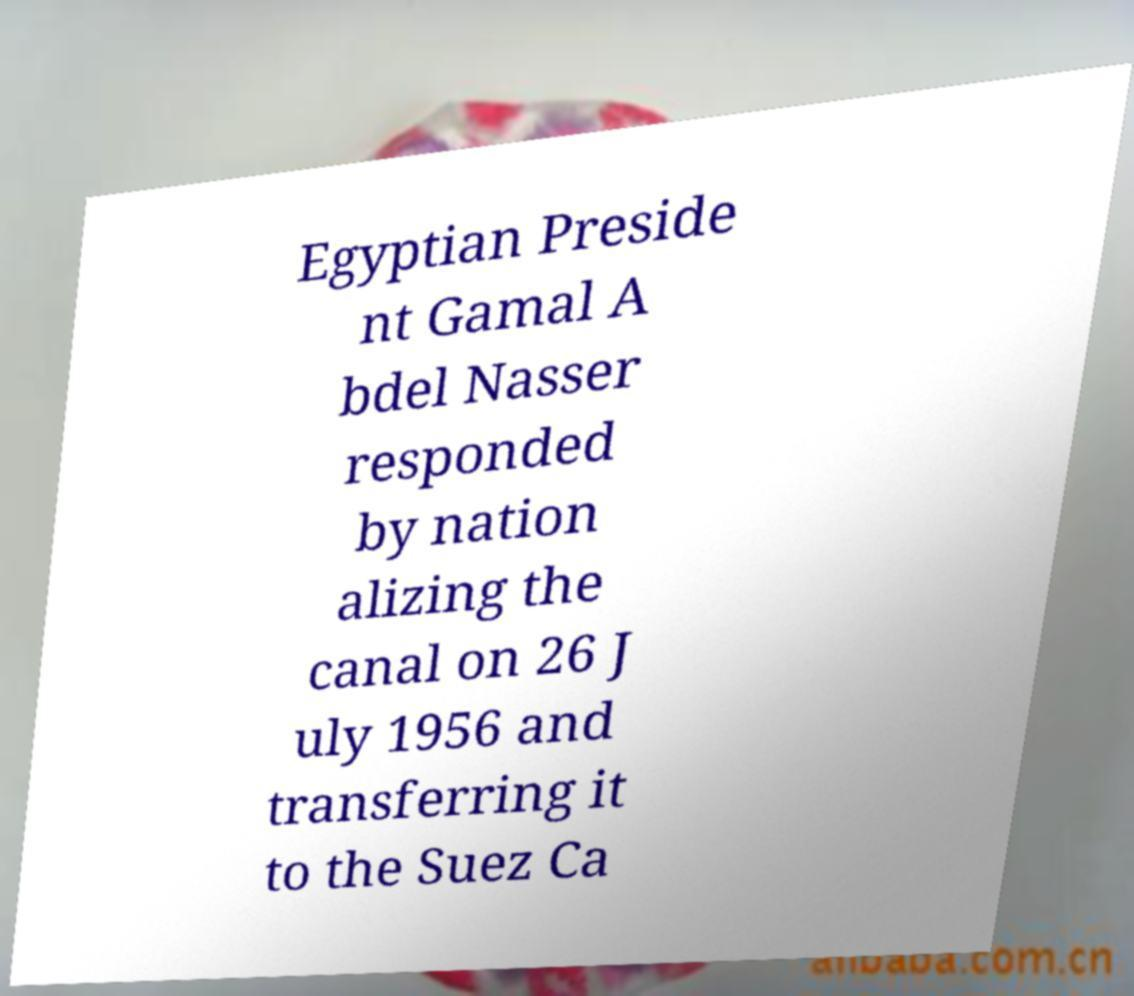Can you read and provide the text displayed in the image?This photo seems to have some interesting text. Can you extract and type it out for me? Egyptian Preside nt Gamal A bdel Nasser responded by nation alizing the canal on 26 J uly 1956 and transferring it to the Suez Ca 